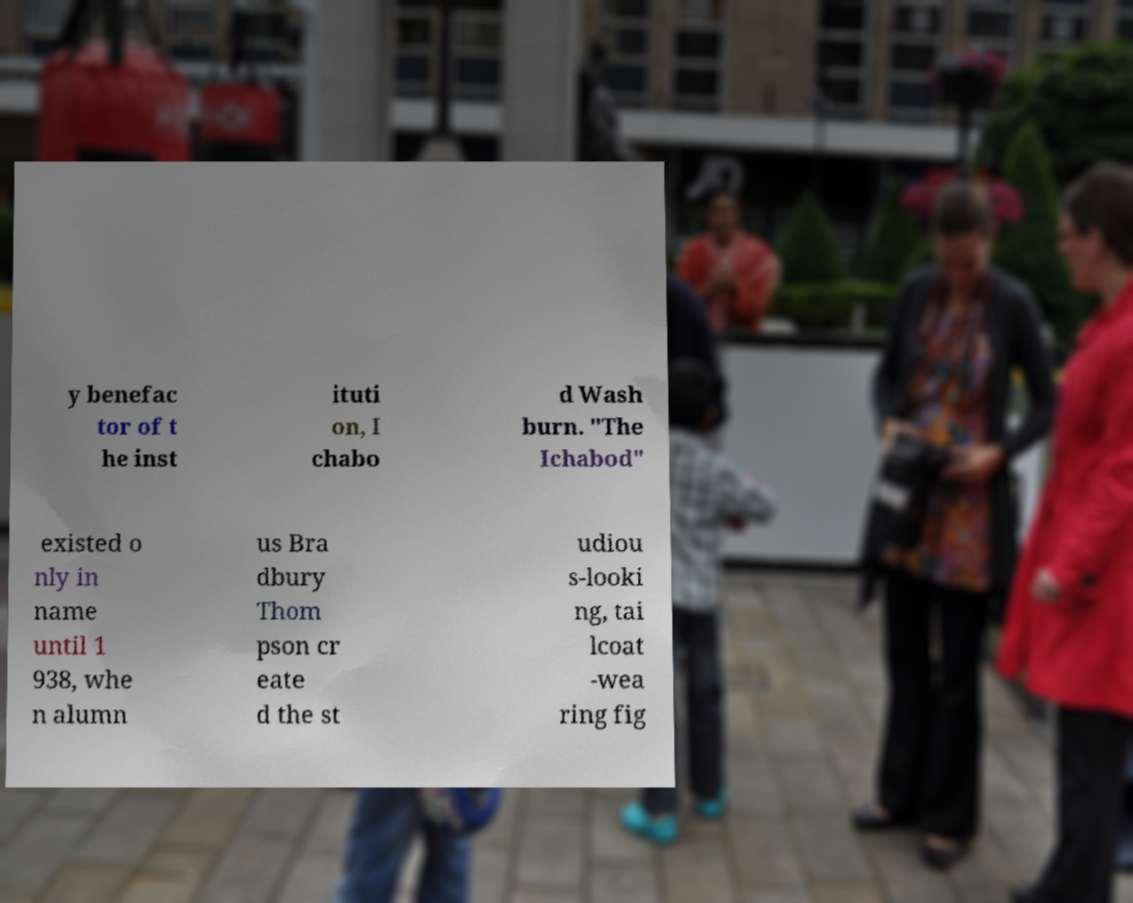Please identify and transcribe the text found in this image. y benefac tor of t he inst ituti on, I chabo d Wash burn. "The Ichabod" existed o nly in name until 1 938, whe n alumn us Bra dbury Thom pson cr eate d the st udiou s-looki ng, tai lcoat -wea ring fig 